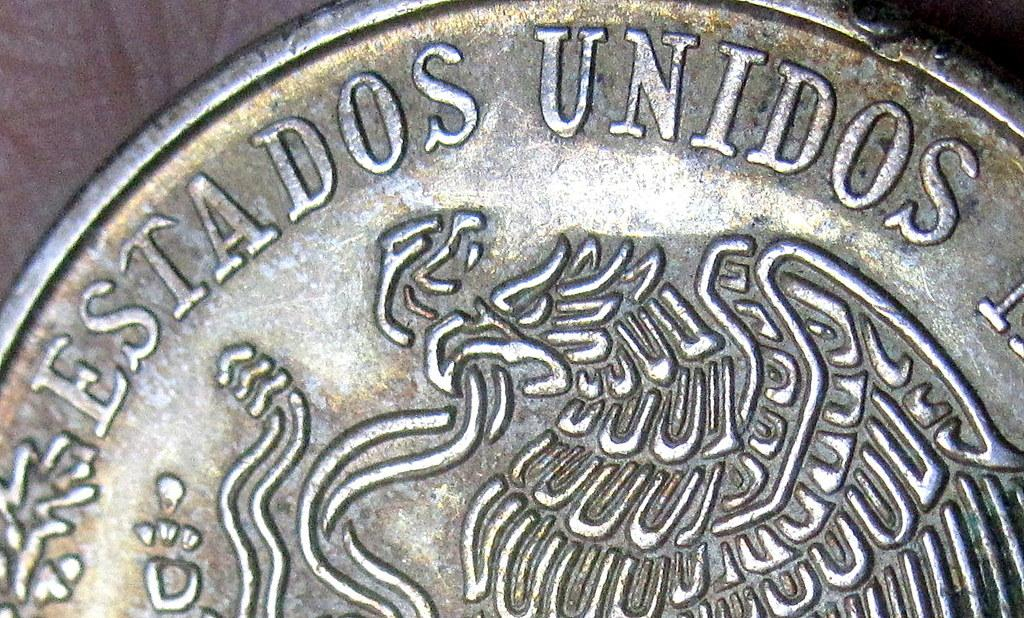<image>
Provide a brief description of the given image. The edge of a silver coin reads estados unidos. 